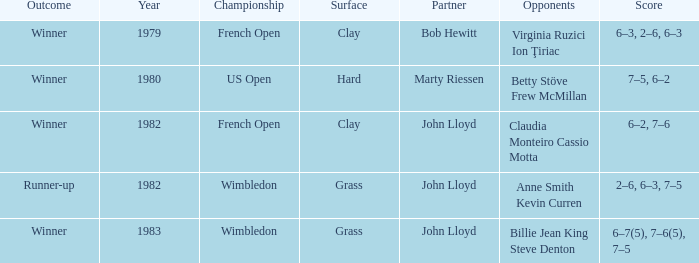Who were the competitors responsible for determining a winner on a grassy terrain? Billie Jean King Steve Denton. 